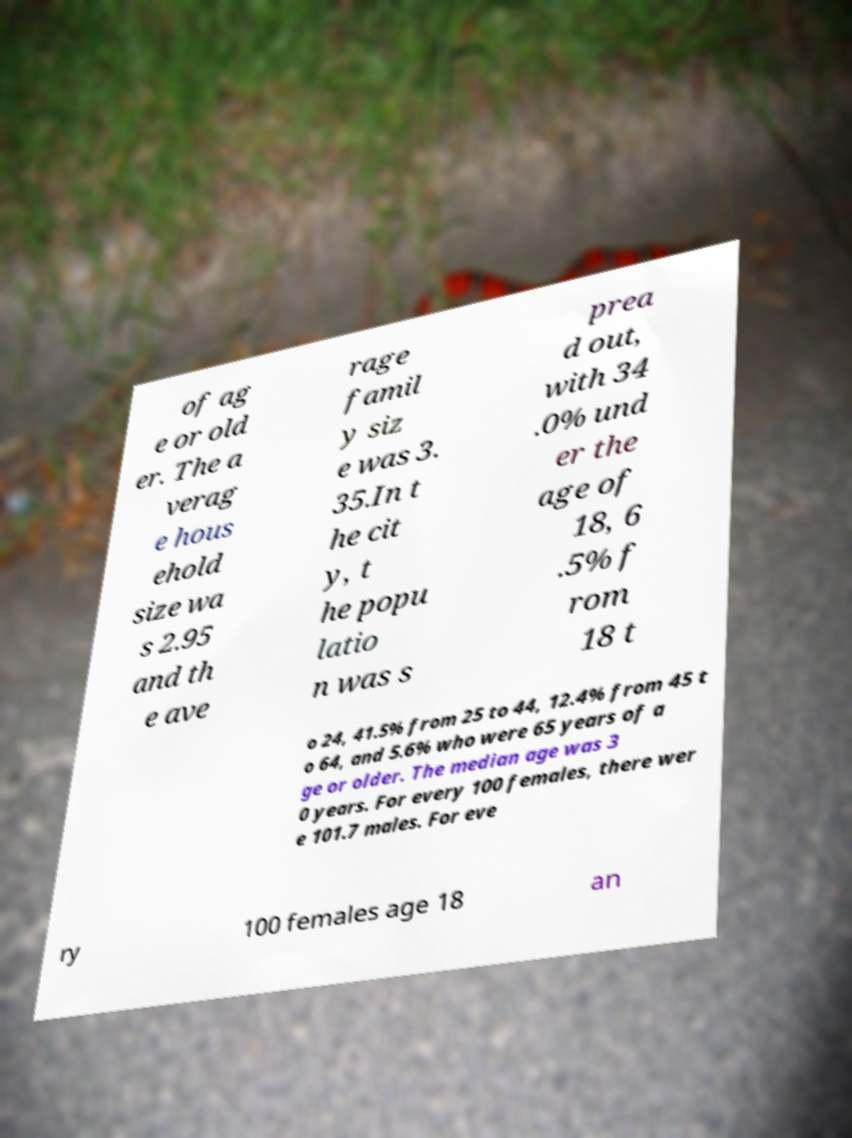There's text embedded in this image that I need extracted. Can you transcribe it verbatim? of ag e or old er. The a verag e hous ehold size wa s 2.95 and th e ave rage famil y siz e was 3. 35.In t he cit y, t he popu latio n was s prea d out, with 34 .0% und er the age of 18, 6 .5% f rom 18 t o 24, 41.5% from 25 to 44, 12.4% from 45 t o 64, and 5.6% who were 65 years of a ge or older. The median age was 3 0 years. For every 100 females, there wer e 101.7 males. For eve ry 100 females age 18 an 